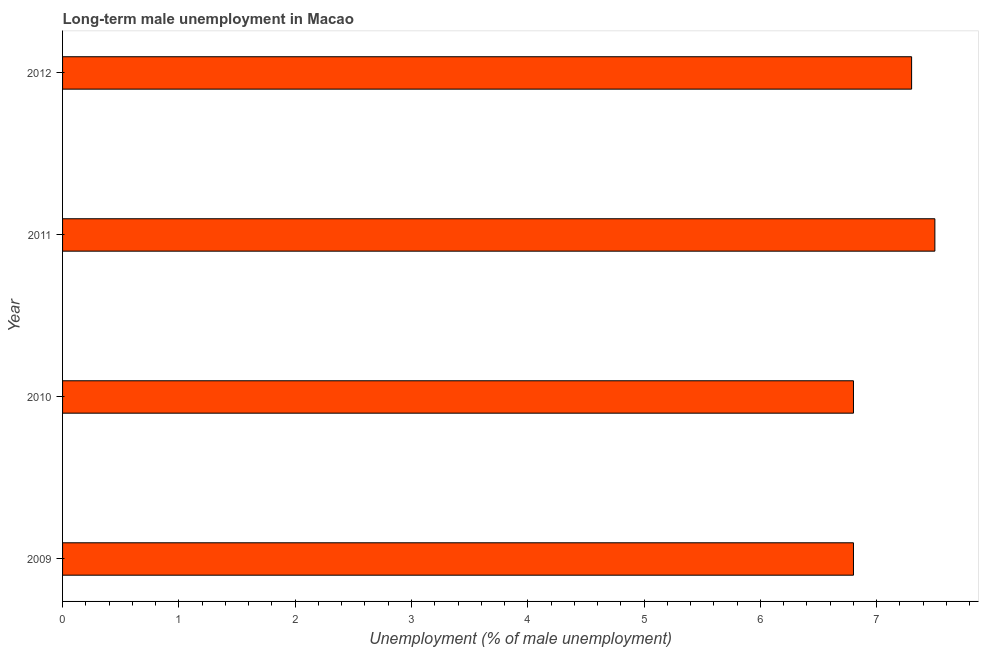Does the graph contain grids?
Offer a very short reply. No. What is the title of the graph?
Your answer should be compact. Long-term male unemployment in Macao. What is the label or title of the X-axis?
Give a very brief answer. Unemployment (% of male unemployment). What is the label or title of the Y-axis?
Provide a short and direct response. Year. What is the long-term male unemployment in 2009?
Keep it short and to the point. 6.8. Across all years, what is the minimum long-term male unemployment?
Provide a succinct answer. 6.8. In which year was the long-term male unemployment maximum?
Offer a terse response. 2011. In which year was the long-term male unemployment minimum?
Give a very brief answer. 2009. What is the sum of the long-term male unemployment?
Offer a very short reply. 28.4. What is the difference between the long-term male unemployment in 2010 and 2011?
Ensure brevity in your answer.  -0.7. What is the average long-term male unemployment per year?
Ensure brevity in your answer.  7.1. What is the median long-term male unemployment?
Your response must be concise. 7.05. In how many years, is the long-term male unemployment greater than 2 %?
Ensure brevity in your answer.  4. What is the ratio of the long-term male unemployment in 2009 to that in 2010?
Ensure brevity in your answer.  1. What is the difference between the highest and the second highest long-term male unemployment?
Your answer should be compact. 0.2. Is the sum of the long-term male unemployment in 2011 and 2012 greater than the maximum long-term male unemployment across all years?
Make the answer very short. Yes. What is the difference between the highest and the lowest long-term male unemployment?
Make the answer very short. 0.7. Are the values on the major ticks of X-axis written in scientific E-notation?
Your response must be concise. No. What is the Unemployment (% of male unemployment) of 2009?
Give a very brief answer. 6.8. What is the Unemployment (% of male unemployment) in 2010?
Offer a terse response. 6.8. What is the Unemployment (% of male unemployment) of 2011?
Make the answer very short. 7.5. What is the Unemployment (% of male unemployment) of 2012?
Your answer should be very brief. 7.3. What is the difference between the Unemployment (% of male unemployment) in 2009 and 2010?
Offer a terse response. 0. What is the difference between the Unemployment (% of male unemployment) in 2010 and 2011?
Ensure brevity in your answer.  -0.7. What is the difference between the Unemployment (% of male unemployment) in 2010 and 2012?
Make the answer very short. -0.5. What is the ratio of the Unemployment (% of male unemployment) in 2009 to that in 2011?
Offer a very short reply. 0.91. What is the ratio of the Unemployment (% of male unemployment) in 2009 to that in 2012?
Offer a very short reply. 0.93. What is the ratio of the Unemployment (% of male unemployment) in 2010 to that in 2011?
Provide a succinct answer. 0.91. What is the ratio of the Unemployment (% of male unemployment) in 2010 to that in 2012?
Keep it short and to the point. 0.93. What is the ratio of the Unemployment (% of male unemployment) in 2011 to that in 2012?
Make the answer very short. 1.03. 